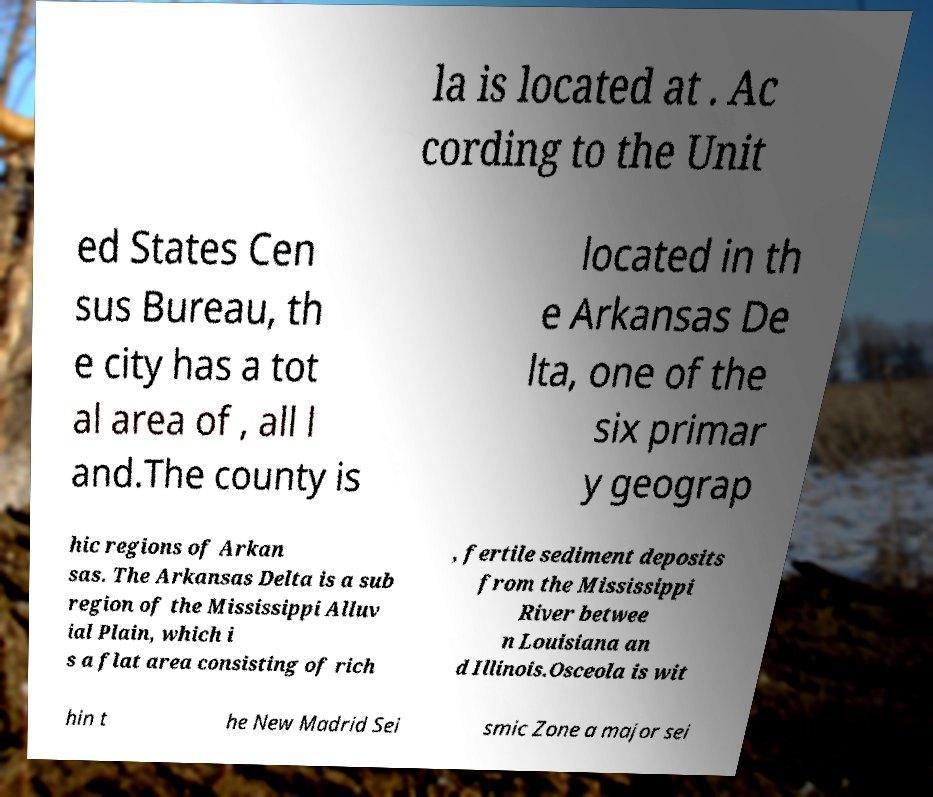There's text embedded in this image that I need extracted. Can you transcribe it verbatim? la is located at . Ac cording to the Unit ed States Cen sus Bureau, th e city has a tot al area of , all l and.The county is located in th e Arkansas De lta, one of the six primar y geograp hic regions of Arkan sas. The Arkansas Delta is a sub region of the Mississippi Alluv ial Plain, which i s a flat area consisting of rich , fertile sediment deposits from the Mississippi River betwee n Louisiana an d Illinois.Osceola is wit hin t he New Madrid Sei smic Zone a major sei 